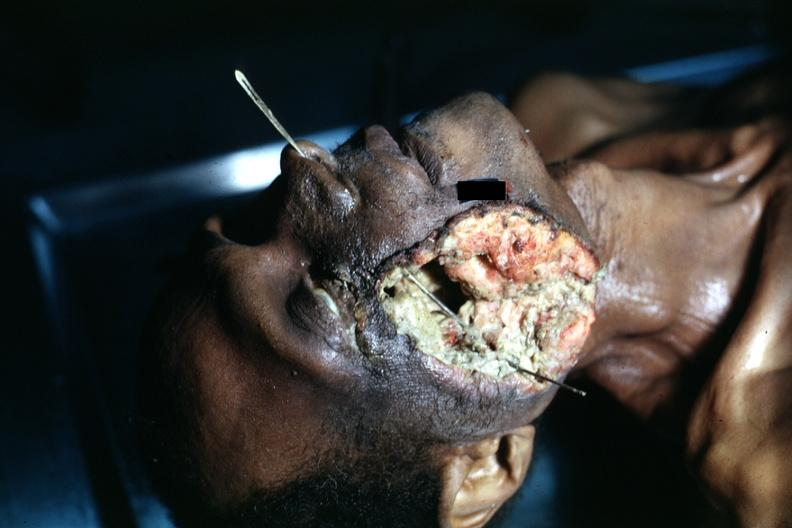s maxillary sinus present?
Answer the question using a single word or phrase. Yes 